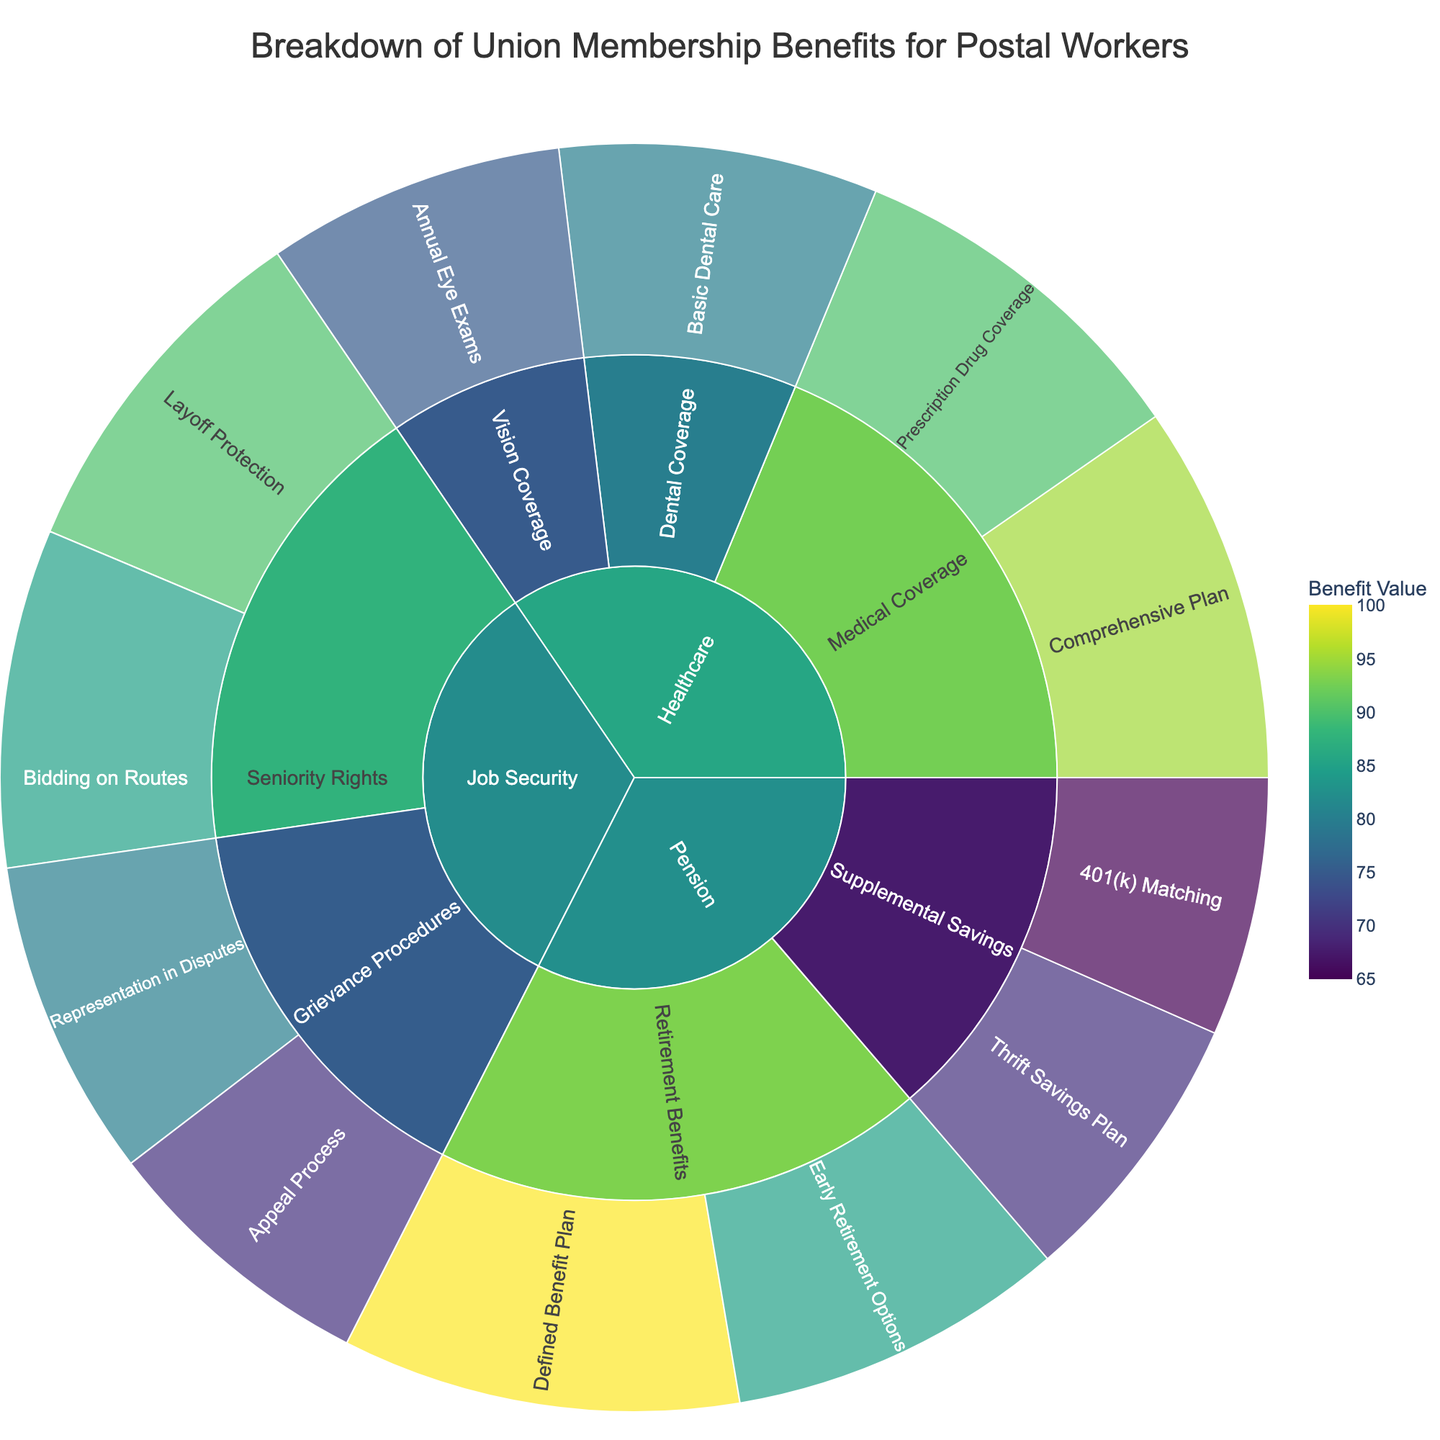What is the title of the figure? The title of a figure is usually prominently displayed at the top, providing an overview of the plot. In this case, the title describes the data being visualized.
Answer: Breakdown of Union Membership Benefits for Postal Workers What is the highest value in the Job Security category? To determine the highest value, look at the leaf nodes under the Job Security category. Compare the values associated with each subcategory under Job Security.
Answer: Layoff Protection (90) Which subcategory under Healthcare has the lowest benefit value? First, locate the Healthcare category, then identify each subcategory under it. Compare the benefit values to find the lowest one.
Answer: Vision Coverage (75) Is the overall benefit value of Pension higher or lower compared to Job Security? Calculate the sum of the benefit values for all subcategories in both Pension and Job Security. Compare the two sums to determine which is higher. Sum of Job Security: 80+70+90+85 = 325. Sum of Pension: 100+85+70+65 = 320.
Answer: Job Security is higher Which benefit has the highest value among all categories? To find the highest value, examine the leaf nodes of every category. Compare the values to identify the maximum one.
Answer: Defined Benefit Plan (100) What is the difference in value between Bidding on Routes and 401(k) Matching? Locate both Bidding on Routes and 401(k) Matching benefits on the plot. Subtract the value of 401(k) Matching from the value of Bidding on Routes.
Answer: 85 - 65 = 20 What are the subcategories under the Pension category? Find the Pension category in the plot, then identify its immediate subcategories.
Answer: Retirement Benefits, Supplemental Savings How many benefits are listed under Healthcare? Locate the Healthcare category and count the number of leaf nodes beneath it, each representing a unique benefit.
Answer: 4 Which is greater: the combined value of all benefits under Medical Coverage or the combined value of all benefits under Grievance Procedures? Sum the values of benefits under Medical Coverage and compare it with the sum of values under Grievance Procedures. Medical Coverage: 95 + 90 = 185. Grievance Procedures: 80 + 70 = 150.
Answer: Medical Coverage is greater What is the average benefit value for the Seniority Rights subcategory? Locate the Seniority Rights subcategory, then find and sum the values of its benefits. Divide the total by the number of benefits to find the average. (Layoff Protection (90) + Bidding on Routes (85)) / 2 = 87.5
Answer: 87.5 